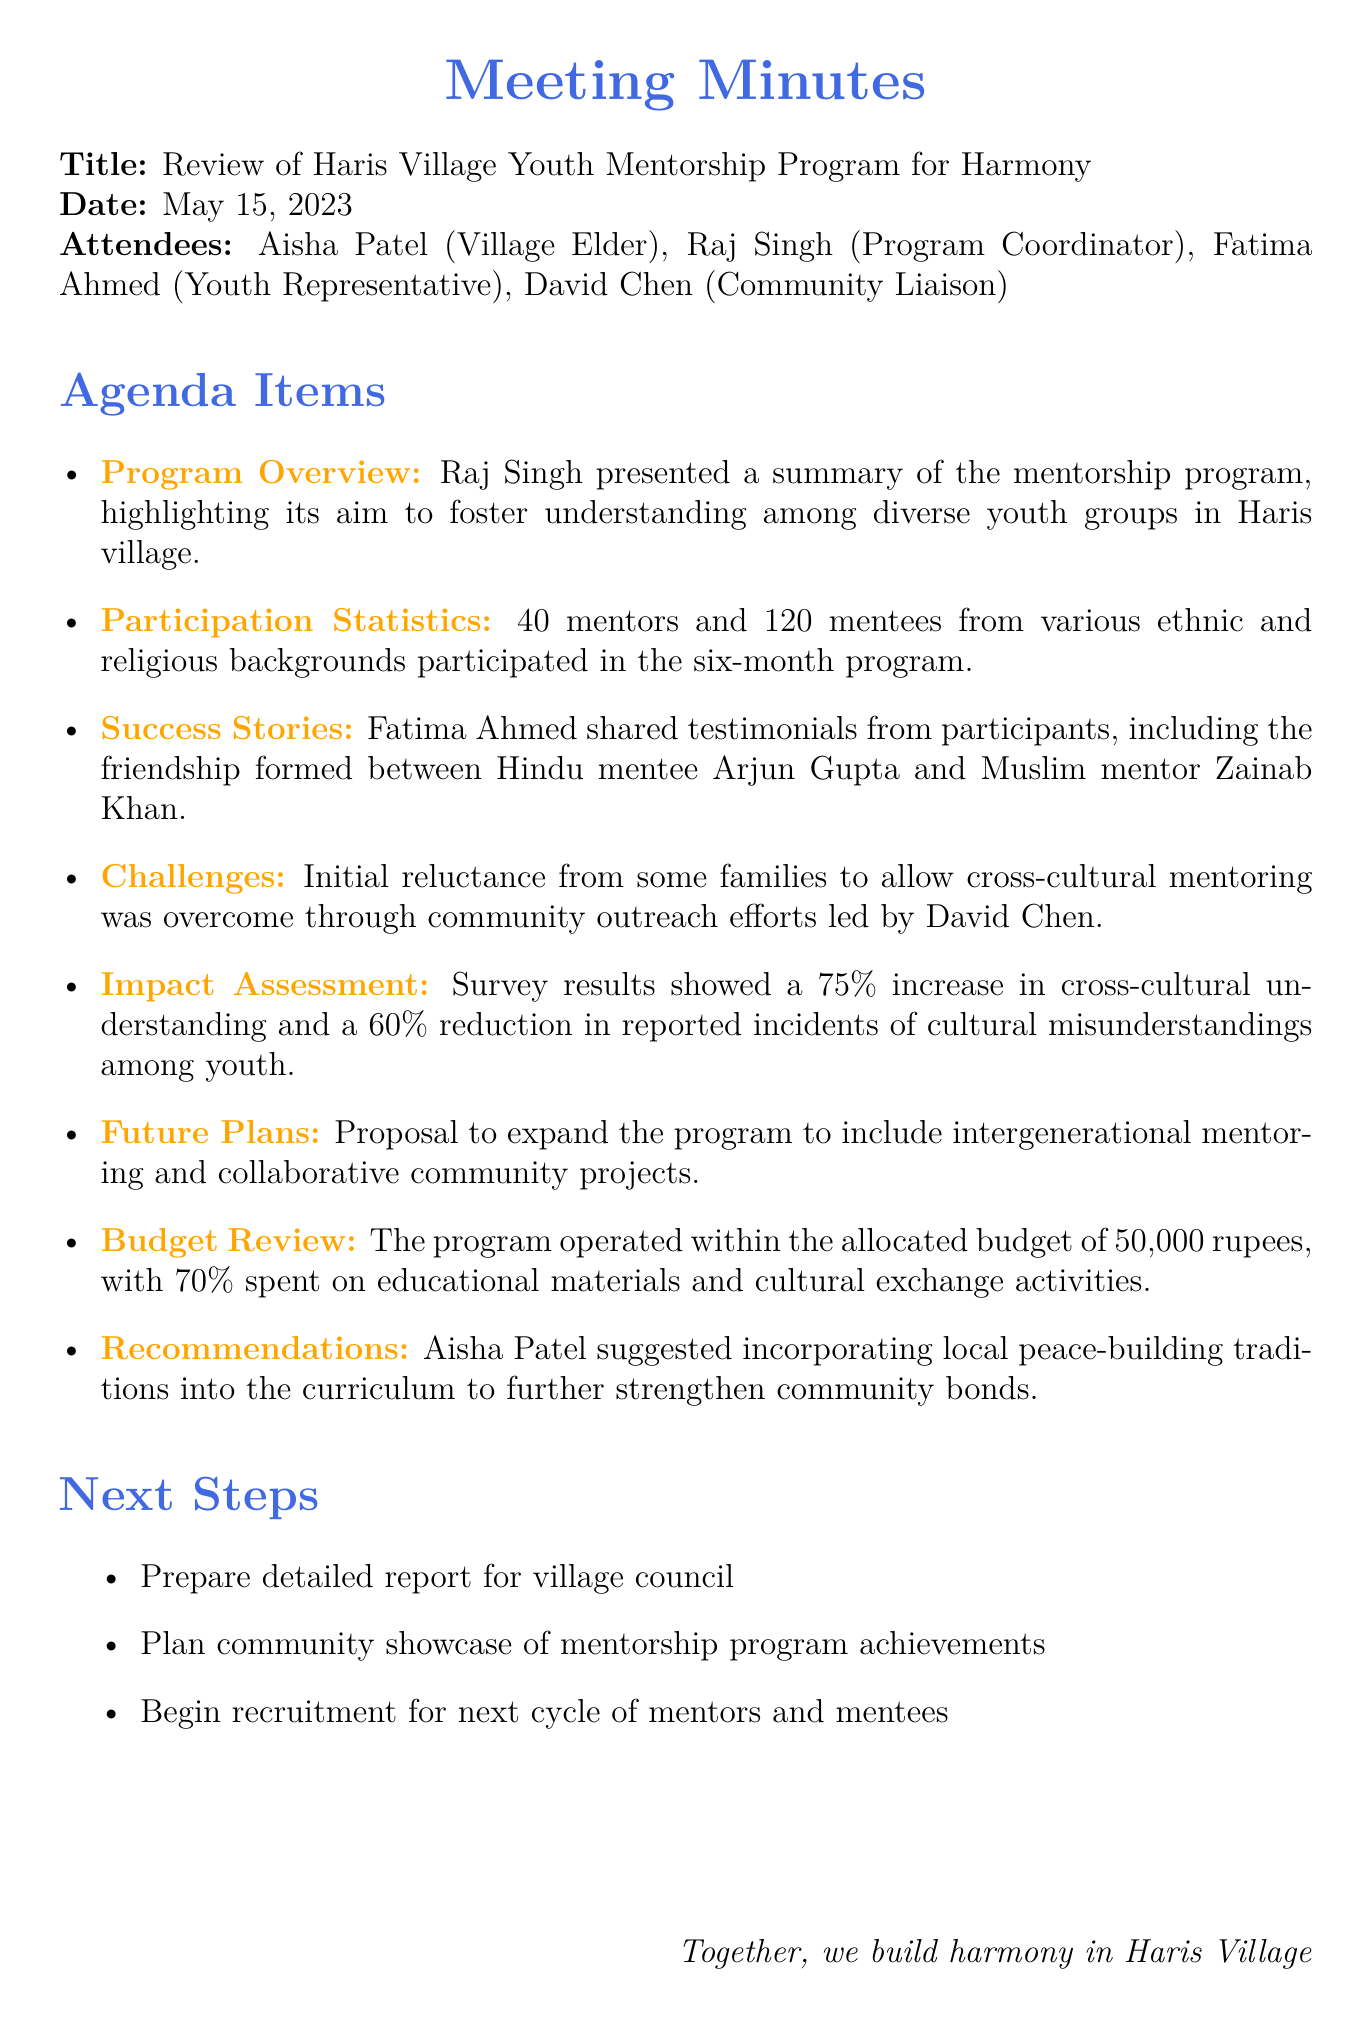What is the title of the meeting? The title of the meeting is stated at the beginning of the document.
Answer: Review of Haris Village Youth Mentorship Program for Harmony Who presented the program overview? The document indicates that Raj Singh presented the summary of the mentorship program.
Answer: Raj Singh How many participants were involved in the mentorship program? The participation statistics section mentions the total number of mentors and mentees.
Answer: 160 What was the percentage increase in cross-cultural understanding? The impact assessment details the percentage increase reported in the document.
Answer: 75% What challenges were addressed during the program? The challenges section outlines specific issues faced during the mentorship program.
Answer: Initial reluctance from some families What recommendation was made to strengthen community bonds? The recommendations section includes a suggestion by Aisha Patel.
Answer: Incorporating local peace-building traditions What is one of the next steps outlined in the document? The next steps section lists actions to be taken following the meeting.
Answer: Prepare detailed report for village council 